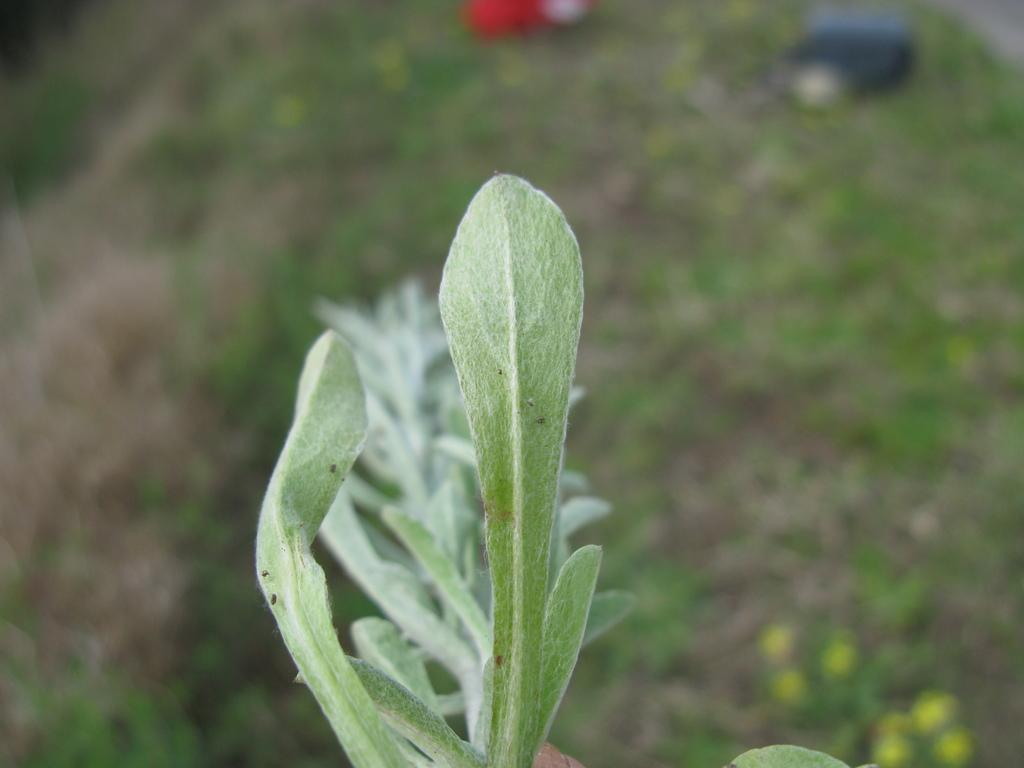What type of vegetation is present in the image? There is a plant and grass visible in the image. How many objects are on the grass in the image? There are two objects on the grass in the image. What are the colors of the two objects on the grass? One object is red in color, and the other object is blue in color. What type of bone can be seen in the image? There is no bone present in the image. What time of day is depicted in the image? The time of day cannot be determined from the image, as there are no specific indicators of time. 